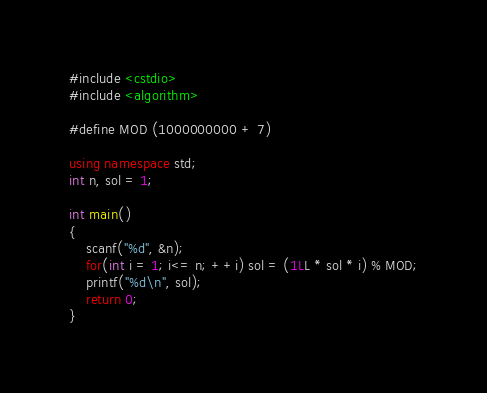Convert code to text. <code><loc_0><loc_0><loc_500><loc_500><_C++_>#include <cstdio>
#include <algorithm>

#define MOD (1000000000 + 7)

using namespace std;
int n, sol = 1;

int main()
{
    scanf("%d", &n);
    for(int i = 1; i<= n; ++i) sol = (1LL * sol * i) % MOD;
    printf("%d\n", sol);
    return 0;
}</code> 